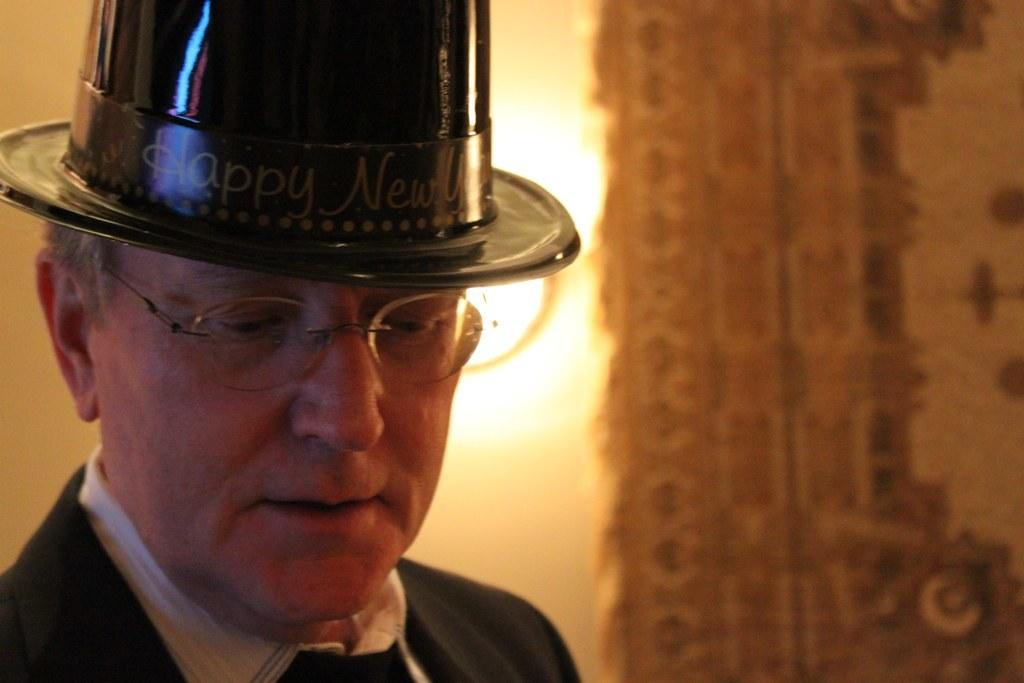What is the main subject of the image? There is a person in the image. Can you describe the background of the image? The background of the image is blurred. What type of agreement is being signed by the person in the image? There is no indication of a person signing an agreement in the image. How many fingers does the person have in the image? The number of fingers on the person's hand cannot be determined from the image, as the person's hand is not visible. 